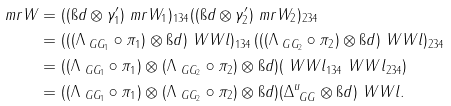Convert formula to latex. <formula><loc_0><loc_0><loc_500><loc_500>\ m r W & = ( ( \i d \otimes \gamma ^ { \prime } _ { 1 } ) \ m r W _ { 1 } ) _ { 1 3 4 } ( ( \i d \otimes \gamma ^ { \prime } _ { 2 } ) \ m r W _ { 2 } ) _ { 2 3 4 } \\ & = ( ( ( \Lambda _ { \ G G _ { 1 } } \circ \pi _ { 1 } ) \otimes \i d ) \ W W l ) _ { 1 3 4 } \, ( ( ( \Lambda _ { \ G G _ { 2 } } \circ \pi _ { 2 } ) \otimes \i d ) \ W W l ) _ { 2 3 4 } \\ & = ( ( \Lambda _ { \ G G _ { 1 } } \circ \pi _ { 1 } ) \otimes ( \Lambda _ { \ G G _ { 2 } } \circ \pi _ { 2 } ) \otimes \i d ) ( \ W W l _ { 1 3 4 } \ W W l _ { 2 3 4 } ) \\ & = ( ( \Lambda _ { \ G G _ { 1 } } \circ \pi _ { 1 } ) \otimes ( \Lambda _ { \ G G _ { 2 } } \circ \pi _ { 2 } ) \otimes \i d ) ( \Delta _ { \ G G } ^ { u } \otimes \i d ) \ W W l .</formula> 